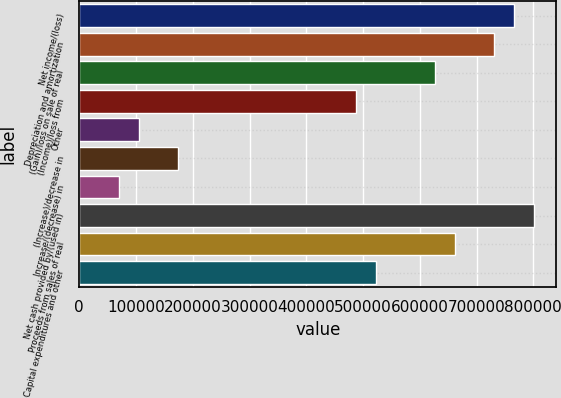<chart> <loc_0><loc_0><loc_500><loc_500><bar_chart><fcel>Net income/(loss)<fcel>Depreciation and amortization<fcel>(Gain)/loss on sale of real<fcel>(Income)/loss from<fcel>Other<fcel>(Increase)/decrease in<fcel>Increase/(decrease) in<fcel>Net cash provided by/(used in)<fcel>Proceeds from sales of real<fcel>Capital expenditures and other<nl><fcel>766087<fcel>731278<fcel>626851<fcel>487616<fcel>104719<fcel>174337<fcel>69910.6<fcel>800895<fcel>661660<fcel>522425<nl></chart> 